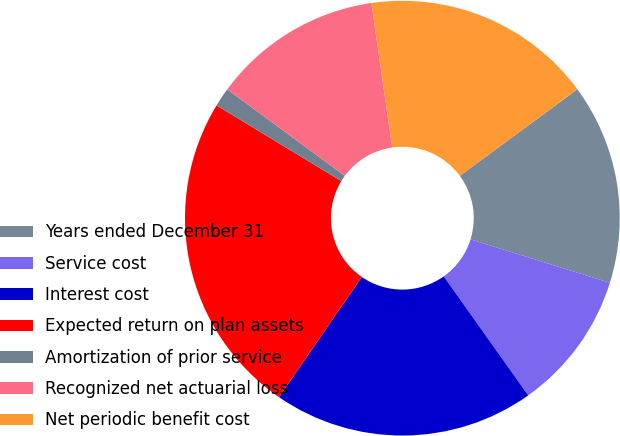Convert chart to OTSL. <chart><loc_0><loc_0><loc_500><loc_500><pie_chart><fcel>Years ended December 31<fcel>Service cost<fcel>Interest cost<fcel>Expected return on plan assets<fcel>Amortization of prior service<fcel>Recognized net actuarial loss<fcel>Net periodic benefit cost<nl><fcel>14.9%<fcel>10.37%<fcel>19.43%<fcel>24.08%<fcel>1.41%<fcel>12.63%<fcel>17.17%<nl></chart> 